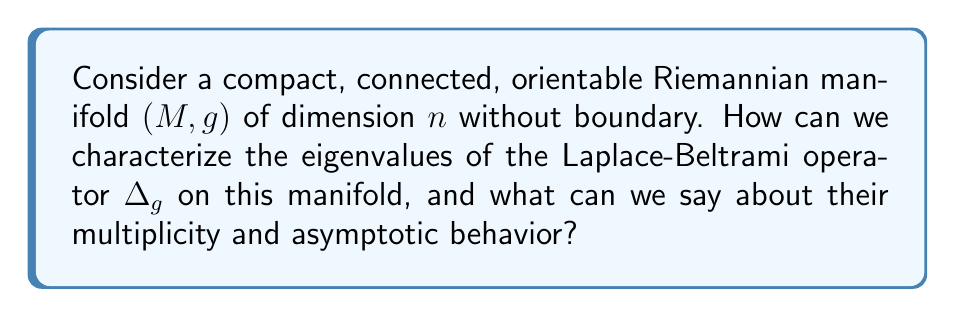Can you answer this question? To characterize the eigenvalues of the Laplace-Beltrami operator on a compact Riemannian manifold, we follow these steps:

1) First, recall that the Laplace-Beltrami operator $\Delta_g$ is a self-adjoint elliptic operator on $L^2(M)$.

2) By the spectral theorem for compact self-adjoint operators, the eigenvalues of $\Delta_g$ form a discrete sequence:

   $$0 = \lambda_0 < \lambda_1 \leq \lambda_2 \leq \cdots \to \infty$$

3) The multiplicity of each eigenvalue is finite, and the corresponding eigenfunctions form an orthonormal basis for $L^2(M)$.

4) The first eigenvalue $\lambda_0 = 0$ corresponds to constant functions, and its multiplicity is 1 since $M$ is connected.

5) For the asymptotic behavior, we can use Weyl's law, which states that:

   $$N(\lambda) \sim \frac{\text{Vol}(B^n)}{(2\pi)^n} \text{Vol}(M) \lambda^{n/2}$$

   where $N(\lambda)$ is the number of eigenvalues less than or equal to $\lambda$, $B^n$ is the unit ball in $\mathbb{R}^n$, and $\text{Vol}(M)$ is the volume of $M$.

6) From Weyl's law, we can deduce that the $k$-th eigenvalue grows asymptotically as:

   $$\lambda_k \sim C_n \left(\frac{k}{\text{Vol}(M)}\right)^{2/n}$$

   where $C_n$ is a constant depending only on the dimension $n$.

7) The multiplicity of eigenvalues can be bounded using Courant's nodal domain theorem, which states that the $k$-th eigenfunction has at most $k$ nodal domains.

8) For certain special manifolds (e.g., spheres, tori), the eigenvalues and their multiplicities can be computed explicitly using separation of variables and harmonic analysis.
Answer: Discrete spectrum $\{\lambda_k\}_{k=0}^{\infty}$, $\lambda_0 = 0$, finite multiplicity, $\lambda_k \sim C_n \left(\frac{k}{\text{Vol}(M)}\right)^{2/n}$ as $k \to \infty$. 